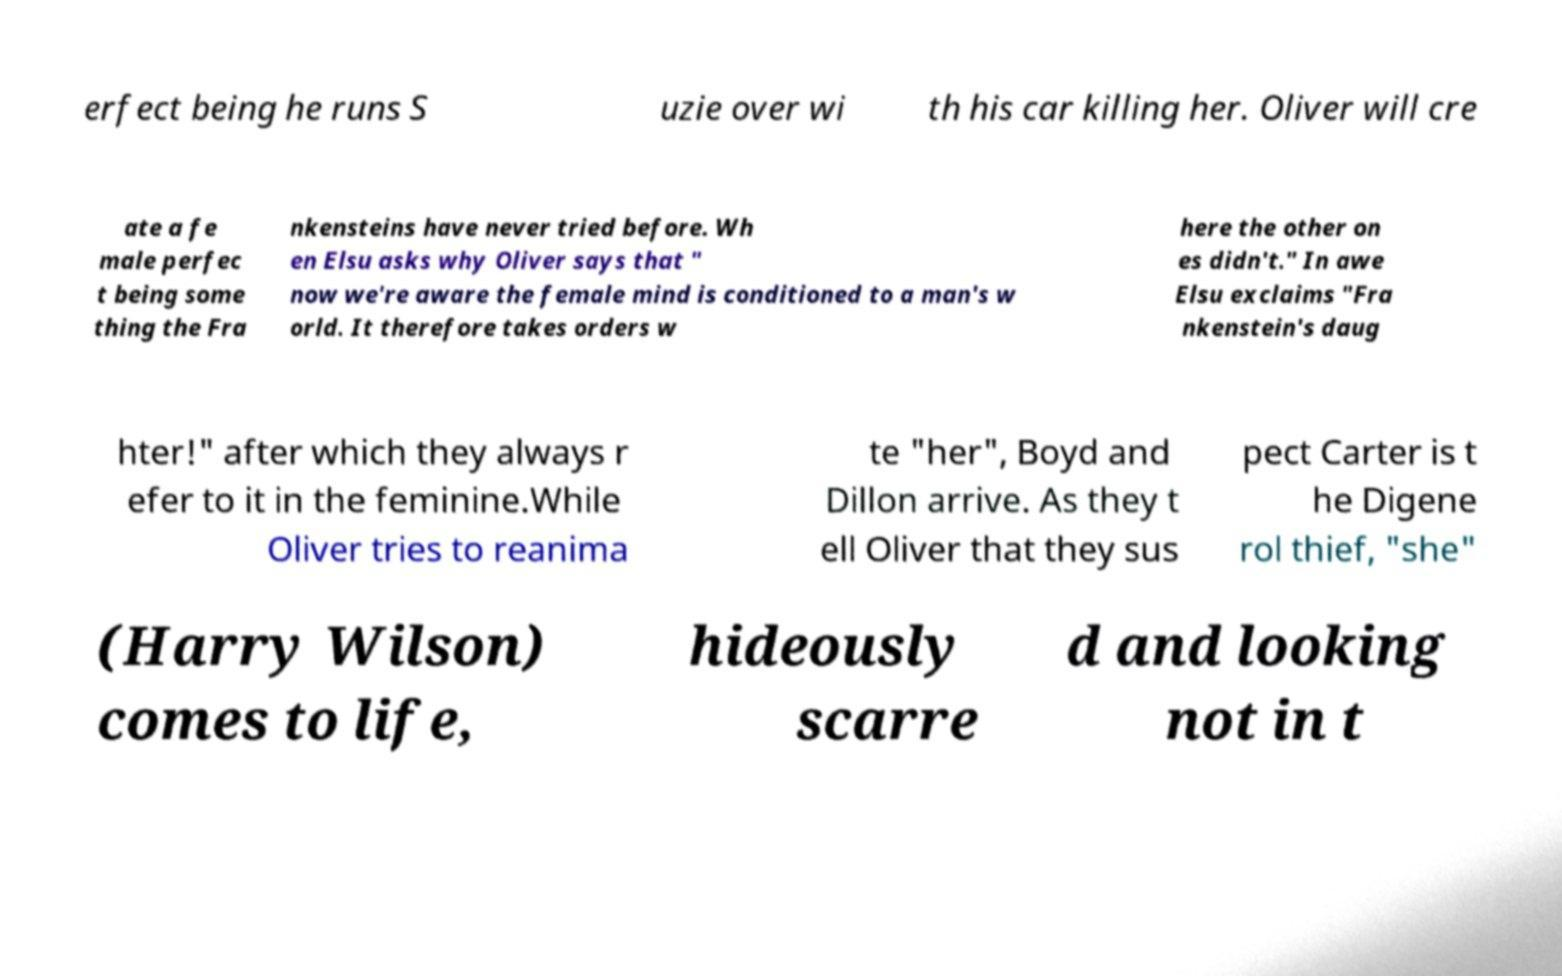Could you assist in decoding the text presented in this image and type it out clearly? erfect being he runs S uzie over wi th his car killing her. Oliver will cre ate a fe male perfec t being some thing the Fra nkensteins have never tried before. Wh en Elsu asks why Oliver says that " now we're aware the female mind is conditioned to a man's w orld. It therefore takes orders w here the other on es didn't." In awe Elsu exclaims "Fra nkenstein's daug hter!" after which they always r efer to it in the feminine.While Oliver tries to reanima te "her", Boyd and Dillon arrive. As they t ell Oliver that they sus pect Carter is t he Digene rol thief, "she" (Harry Wilson) comes to life, hideously scarre d and looking not in t 